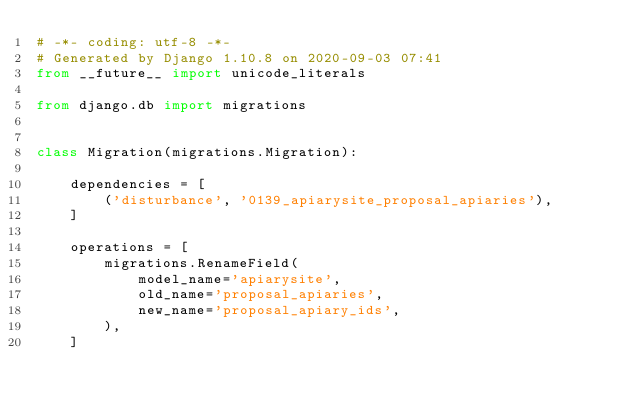<code> <loc_0><loc_0><loc_500><loc_500><_Python_># -*- coding: utf-8 -*-
# Generated by Django 1.10.8 on 2020-09-03 07:41
from __future__ import unicode_literals

from django.db import migrations


class Migration(migrations.Migration):

    dependencies = [
        ('disturbance', '0139_apiarysite_proposal_apiaries'),
    ]

    operations = [
        migrations.RenameField(
            model_name='apiarysite',
            old_name='proposal_apiaries',
            new_name='proposal_apiary_ids',
        ),
    ]
</code> 